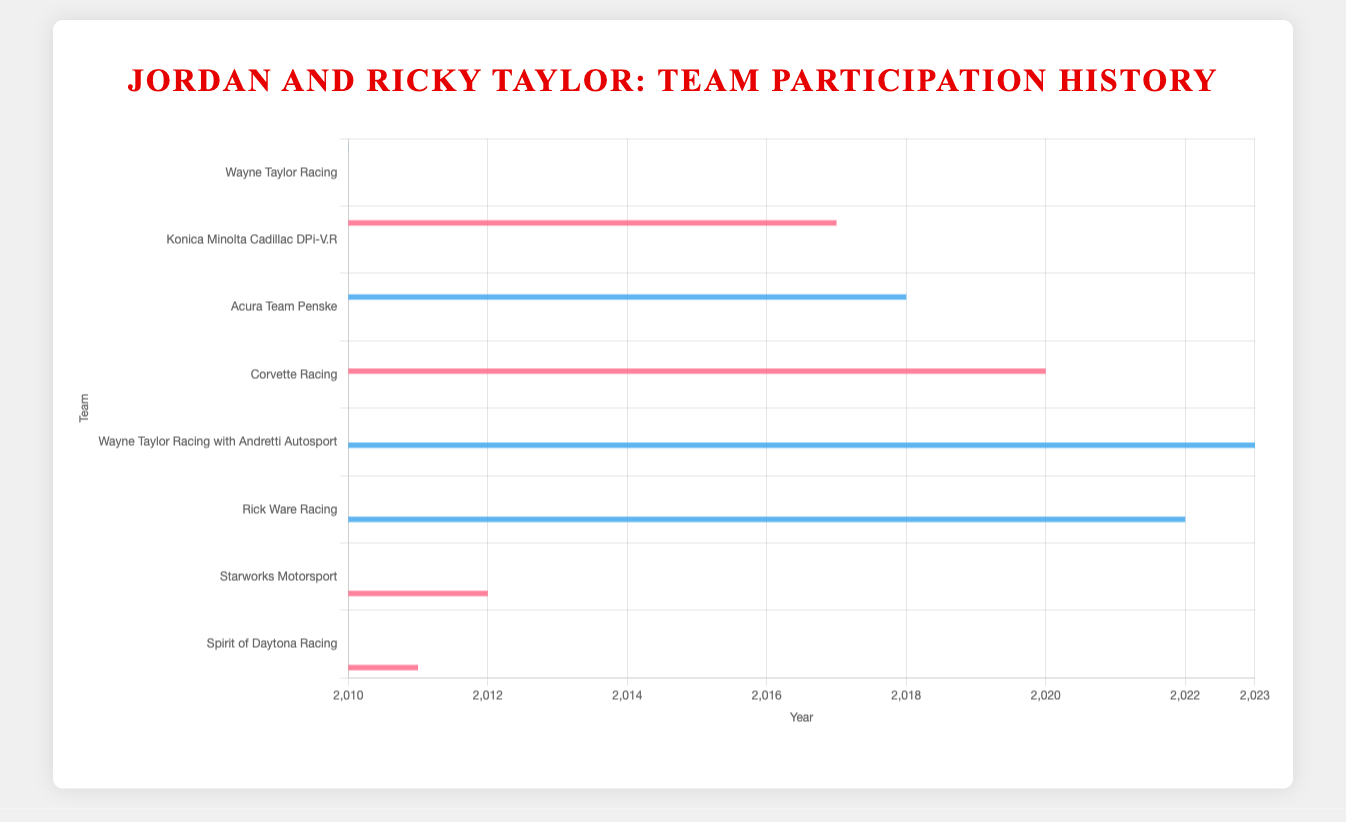How many years did both Jordan and Ricky Taylor participate with Wayne Taylor Racing? Ricky Taylor participated from 2010 to 2017, and Jordan Taylor from 2013 to 2019. Their overlapping years are 2013, 2014, 2015, 2016, and 2017. The count of overlapping years is 5.
Answer: 5 Which team did Jordan Taylor join after leaving Wayne Taylor Racing? Jordan Taylor was with Wayne Taylor Racing until 2019. The next team listed for him starting from 2020 is Corvette Racing.
Answer: Corvette Racing Who had more years with Konica Minolta Cadillac DPi-V.R, Jordan or Ricky Taylor? Ricky Taylor participated only in 2017, while Jordan Taylor participated from 2017 to 2019. Jordan Taylor had more years.
Answer: Jordan Taylor In total, how many different teams have both Jordan and Ricky Taylor participated with? Ricky Taylor has participated with 5 different teams (Wayne Taylor Racing, Konica Minolta Cadillac DPi-V.R, Acura Team Penske, Wayne Taylor Racing with Andretti Autosport, and Rick Ware Racing). Jordan Taylor has participated with 4 teams (Wayne Taylor Racing, Konica Minolta Cadillac DPi-V.R, Corvette Racing, Starworks Motorsport, and Spirit of Daytona Racing). They both have participated with 2 common teams: Wayne Taylor Racing and Konica Minolta Cadillac DPi-V.R.
Answer: 2 In which years did Jordan Taylor and Ricky Taylor both not participate with any same team? Jordan Taylor and Ricky Taylor shared teams in 2011 (Wayne Taylor Racing), 2012 (Wayne Taylor Racing), 2013 (Wayne Taylor Racing), 2014 (Wayne Taylor Racing), 2015 (Wayne Taylor Racing), 2016 (Wayne Taylor Racing), 2017 (Wayne Taylor Racing and Konica Minolta Cadillac DPi-V.R). Years they both did not share a team are from 2018-2023.
Answer: 2018-2023 Which team has the longest consecutive participation for Ricky Taylor? Ricky Taylor participated with Wayne Taylor Racing from 2010 to 2017 consecutively. This is the longest consecutive span for any team.
Answer: Wayne Taylor Racing During which years did Jordan Taylor race with Starworks Motorsport? Jordan Taylor raced with Starworks Motorsport in 2012.
Answer: 2012 What is the overlapping period, if any, of Ricky Taylor with Acura Team Penske and Jordan Taylor with Corvette Racing? Ricky Taylor was with Acura Team Penske from 2018 to 2021. Jordan Taylor joined Corvette Racing in 2020. The overlapping period is 2020 and 2021.
Answer: 2020, 2021 Which team did Ricky Taylor join after Wayne Taylor Racing? Ricky Taylor was with Wayne Taylor Racing until 2017 and the next team he joined in 2018 was Acura Team Penske.
Answer: Acura Team Penske 